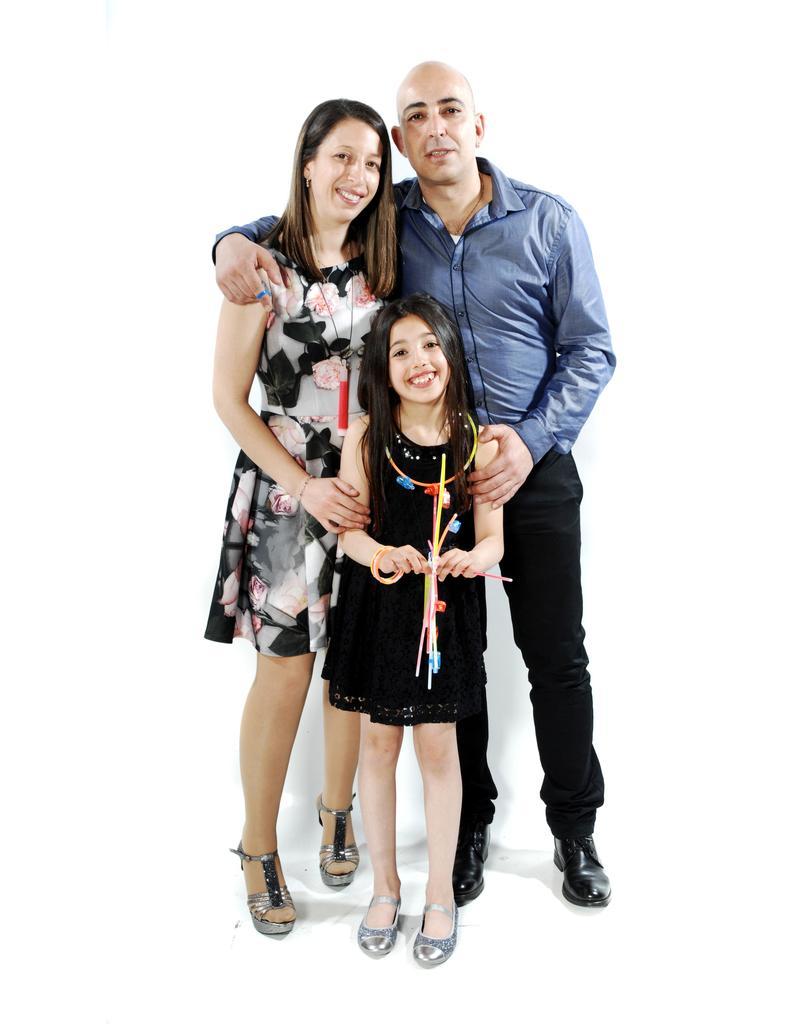Can you describe this image briefly? In the picture we can see man wearing blue color shirt, black color pant, woman wearing black and white color dress and a kid wearing black color dress standing and posing for a photograph. 